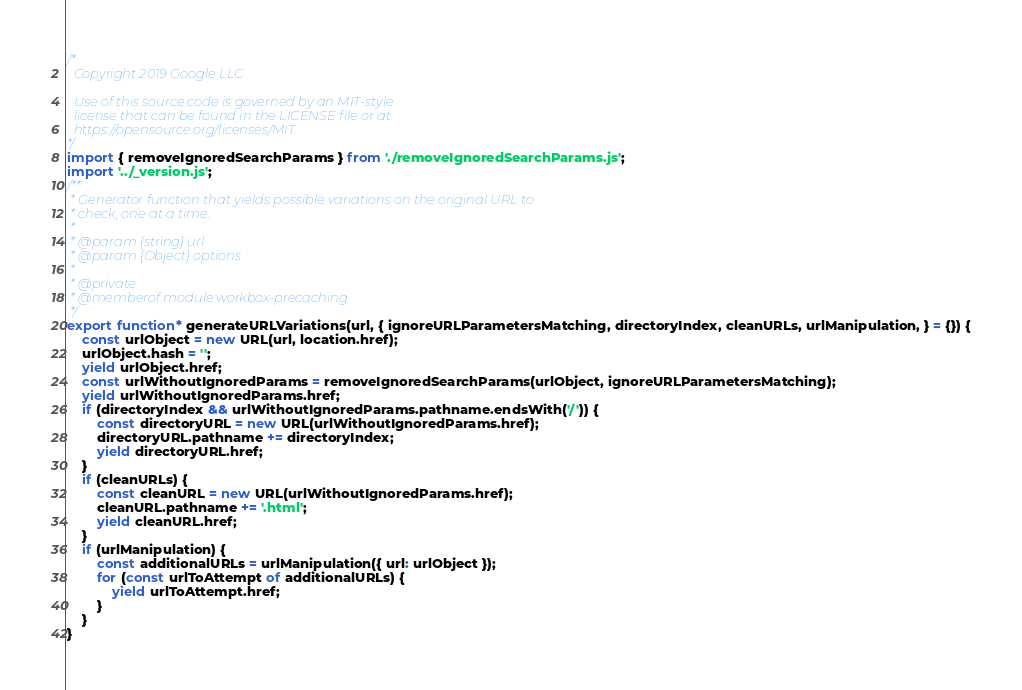Convert code to text. <code><loc_0><loc_0><loc_500><loc_500><_JavaScript_>/*
  Copyright 2019 Google LLC

  Use of this source code is governed by an MIT-style
  license that can be found in the LICENSE file or at
  https://opensource.org/licenses/MIT.
*/
import { removeIgnoredSearchParams } from './removeIgnoredSearchParams.js';
import '../_version.js';
/**
 * Generator function that yields possible variations on the original URL to
 * check, one at a time.
 *
 * @param {string} url
 * @param {Object} options
 *
 * @private
 * @memberof module:workbox-precaching
 */
export function* generateURLVariations(url, { ignoreURLParametersMatching, directoryIndex, cleanURLs, urlManipulation, } = {}) {
    const urlObject = new URL(url, location.href);
    urlObject.hash = '';
    yield urlObject.href;
    const urlWithoutIgnoredParams = removeIgnoredSearchParams(urlObject, ignoreURLParametersMatching);
    yield urlWithoutIgnoredParams.href;
    if (directoryIndex && urlWithoutIgnoredParams.pathname.endsWith('/')) {
        const directoryURL = new URL(urlWithoutIgnoredParams.href);
        directoryURL.pathname += directoryIndex;
        yield directoryURL.href;
    }
    if (cleanURLs) {
        const cleanURL = new URL(urlWithoutIgnoredParams.href);
        cleanURL.pathname += '.html';
        yield cleanURL.href;
    }
    if (urlManipulation) {
        const additionalURLs = urlManipulation({ url: urlObject });
        for (const urlToAttempt of additionalURLs) {
            yield urlToAttempt.href;
        }
    }
}
</code> 